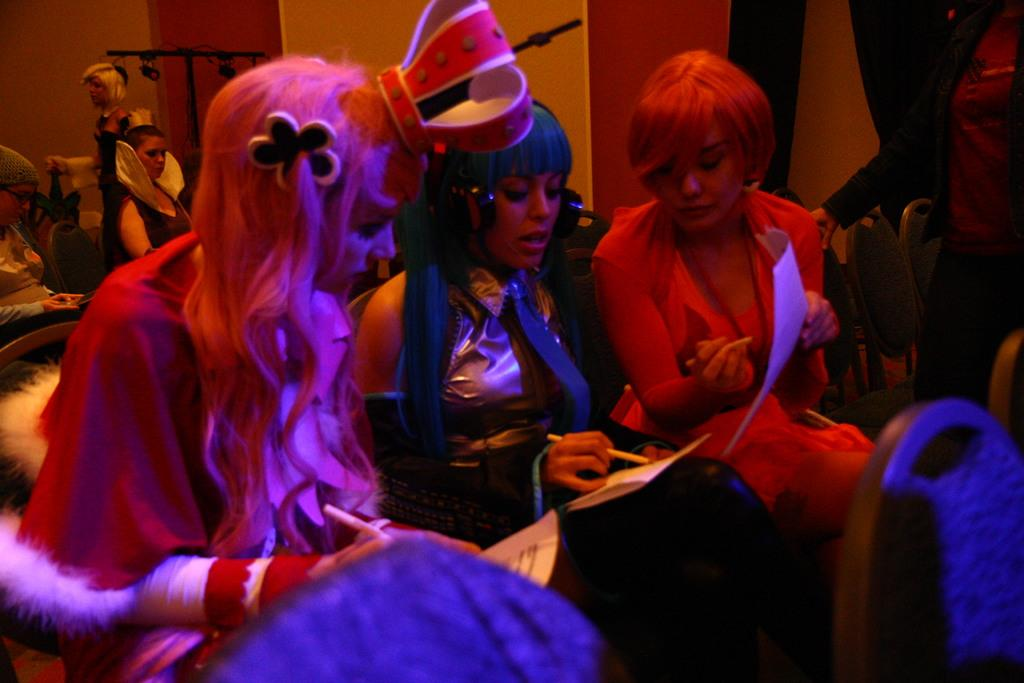What are the people in the image doing? The people in the image are sitting. What are the people wearing? The people are wearing fancy dresses. What objects are the people holding? The people are holding papers and pens. What type of furniture is present in the image? There are chairs in the image. What can be seen in the background of the image? There is a wall and people in the background of the image, as well as a stand. What type of creature is sitting next to the person holding a pen in the image? There is no creature present in the image; only people are visible. Can you tell me how many bars of soap are on the stand in the background of the image? There is no soap present in the image; only a stand can be seen in the background. 